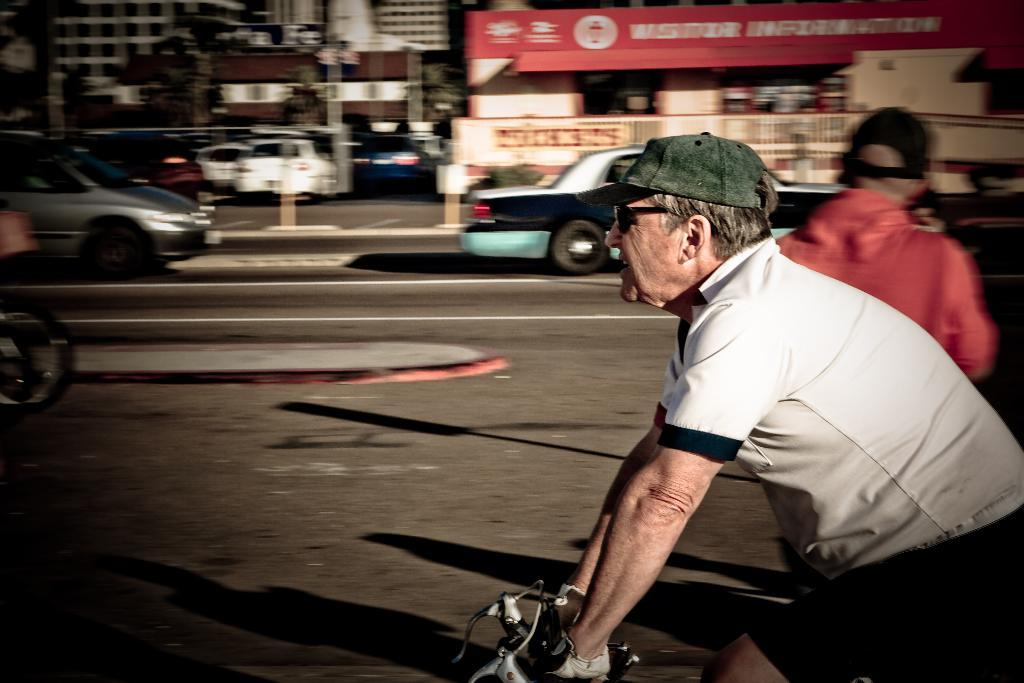Who is the main subject in the image? There is an old man in the image. What is the old man doing in the image? The old man is riding a bicycle. What can be seen in the background of the image? There are many cars and buildings in the background of the image. How are the buildings in the background depicted? The buildings in the background are slightly blurred. Can you see a baby in the image? There is no baby present in the image. 